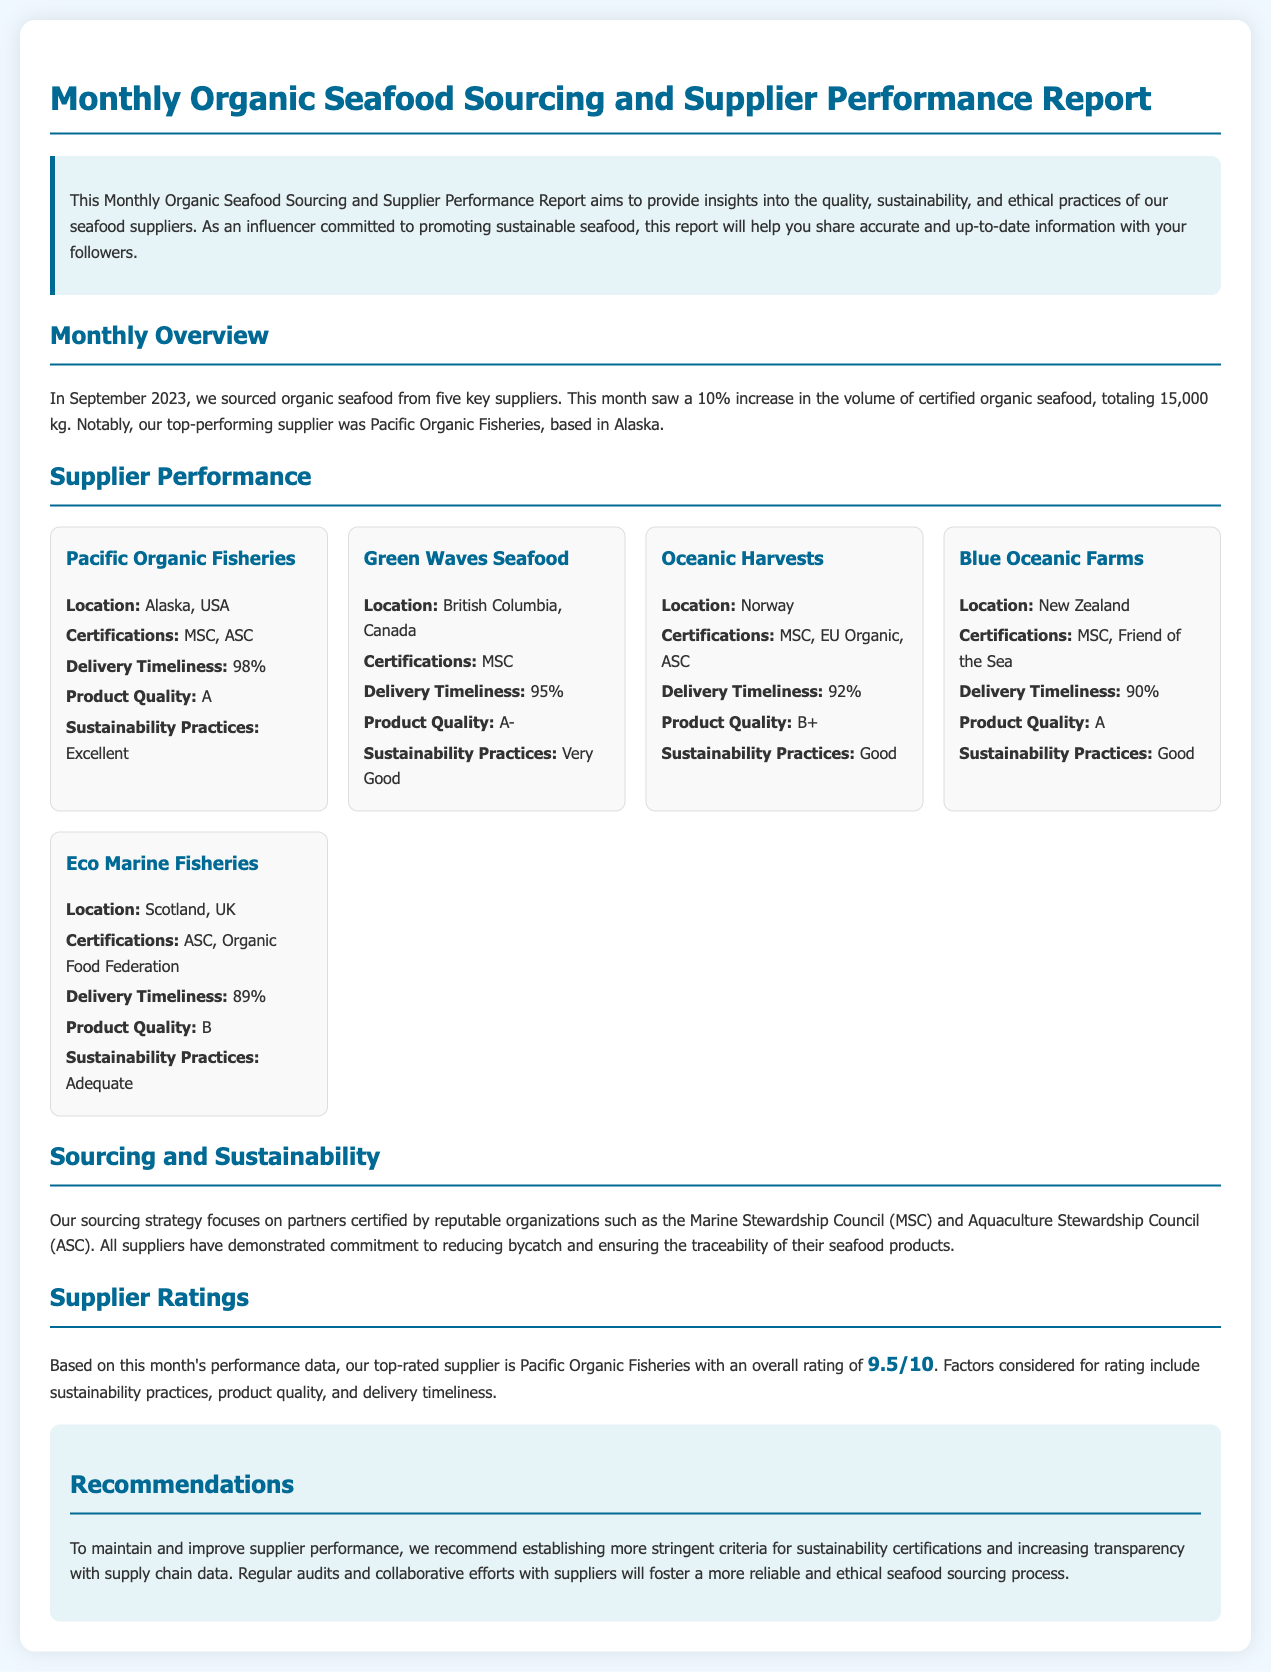What was the total volume of certified organic seafood sourced in September 2023? The total volume of certified organic seafood sourced is mentioned as 15,000 kg in the document.
Answer: 15,000 kg Who was the top-performing supplier in September 2023? The document states that Pacific Organic Fisheries was the top-performing supplier for the month.
Answer: Pacific Organic Fisheries What is the delivery timeliness percentage for Eco Marine Fisheries? The document indicates that the delivery timeliness for Eco Marine Fisheries is 89%.
Answer: 89% What certification does Oceanic Harvests hold? The document lists the certifications for Oceanic Harvests, which include MSC, EU Organic, and ASC.
Answer: MSC, EU Organic, ASC Which supplier has the highest product quality rating? The document identifies Pacific Organic Fisheries with a product quality rating of A as the highest.
Answer: A What recommendations are provided to improve supplier performance? The recommendations suggest establishing more stringent criteria for sustainability certifications.
Answer: More stringent criteria for sustainability certifications Which supplier is located in Scotland? The document states that Eco Marine Fisheries is located in Scotland, UK.
Answer: Eco Marine Fisheries What overall rating did Pacific Organic Fisheries receive this month? The overall rating for Pacific Organic Fisheries mentioned in the document is 9.5/10.
Answer: 9.5/10 